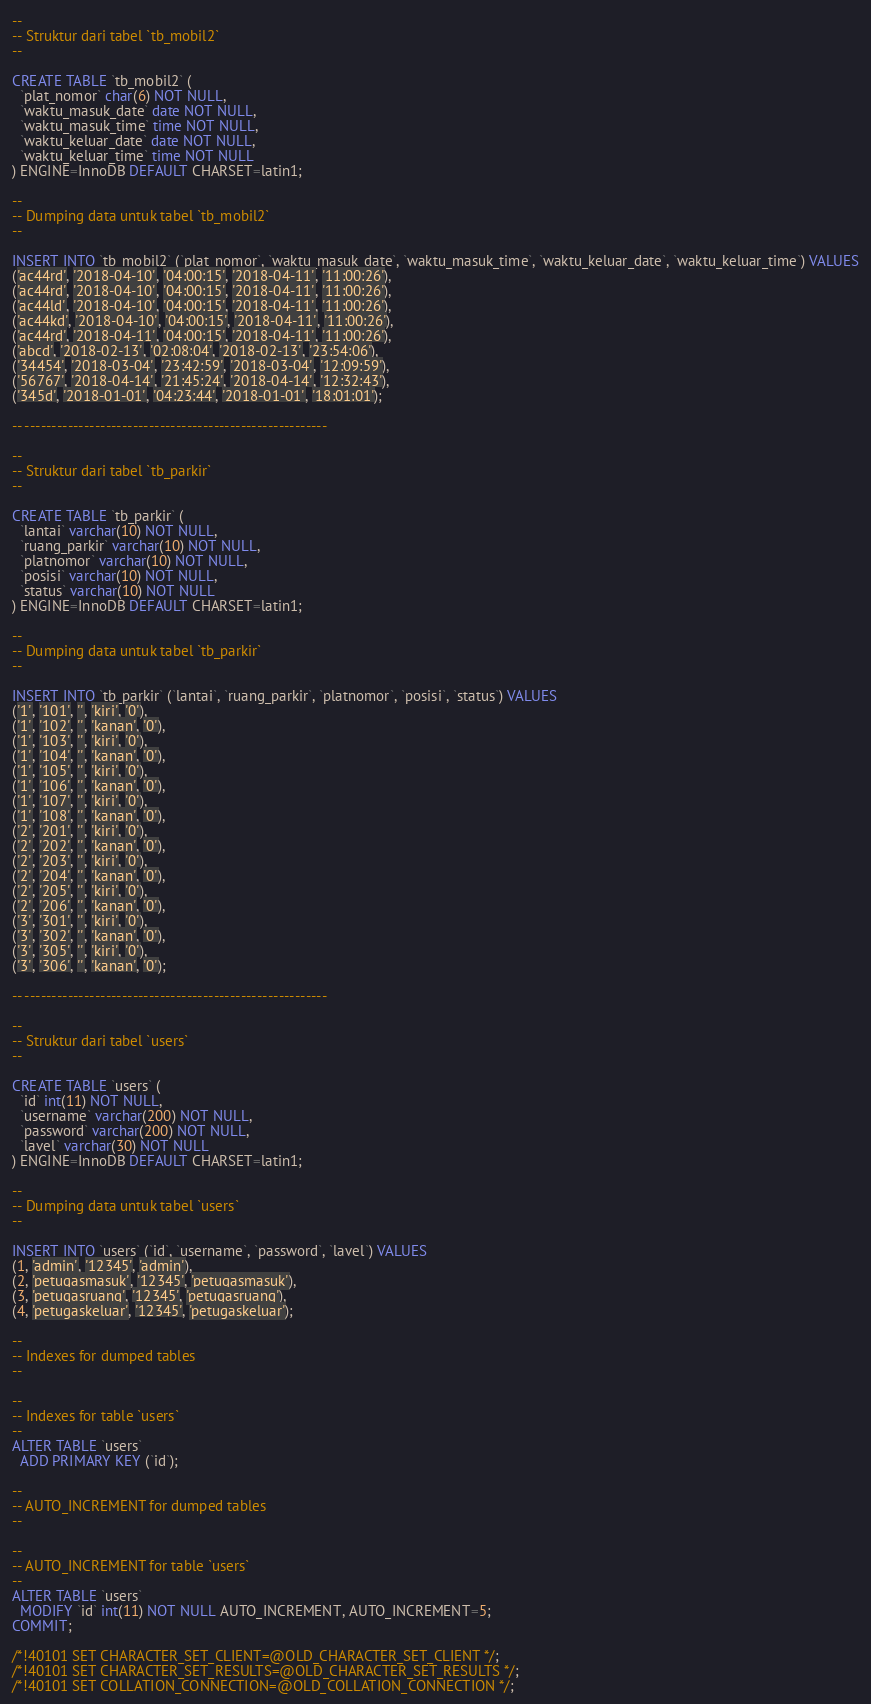<code> <loc_0><loc_0><loc_500><loc_500><_SQL_>
--
-- Struktur dari tabel `tb_mobil2`
--

CREATE TABLE `tb_mobil2` (
  `plat_nomor` char(6) NOT NULL,
  `waktu_masuk_date` date NOT NULL,
  `waktu_masuk_time` time NOT NULL,
  `waktu_keluar_date` date NOT NULL,
  `waktu_keluar_time` time NOT NULL
) ENGINE=InnoDB DEFAULT CHARSET=latin1;

--
-- Dumping data untuk tabel `tb_mobil2`
--

INSERT INTO `tb_mobil2` (`plat_nomor`, `waktu_masuk_date`, `waktu_masuk_time`, `waktu_keluar_date`, `waktu_keluar_time`) VALUES
('ac44rd', '2018-04-10', '04:00:15', '2018-04-11', '11:00:26'),
('ac44rd', '2018-04-10', '04:00:15', '2018-04-11', '11:00:26'),
('ac44ld', '2018-04-10', '04:00:15', '2018-04-11', '11:00:26'),
('ac44kd', '2018-04-10', '04:00:15', '2018-04-11', '11:00:26'),
('ac44rd', '2018-04-11', '04:00:15', '2018-04-11', '11:00:26'),
('abcd', '2018-02-13', '02:08:04', '2018-02-13', '23:54:06'),
('34454', '2018-03-04', '23:42:59', '2018-03-04', '12:09:59'),
('56767', '2018-04-14', '21:45:24', '2018-04-14', '12:32:43'),
('345d', '2018-01-01', '04:23:44', '2018-01-01', '18:01:01');

-- --------------------------------------------------------

--
-- Struktur dari tabel `tb_parkir`
--

CREATE TABLE `tb_parkir` (
  `lantai` varchar(10) NOT NULL,
  `ruang_parkir` varchar(10) NOT NULL,
  `platnomor` varchar(10) NOT NULL,
  `posisi` varchar(10) NOT NULL,
  `status` varchar(10) NOT NULL
) ENGINE=InnoDB DEFAULT CHARSET=latin1;

--
-- Dumping data untuk tabel `tb_parkir`
--

INSERT INTO `tb_parkir` (`lantai`, `ruang_parkir`, `platnomor`, `posisi`, `status`) VALUES
('1', '101', '', 'kiri', '0'),
('1', '102', '', 'kanan', '0'),
('1', '103', '', 'kiri', '0'),
('1', '104', '', 'kanan', '0'),
('1', '105', '', 'kiri', '0'),
('1', '106', '', 'kanan', '0'),
('1', '107', '', 'kiri', '0'),
('1', '108', '', 'kanan', '0'),
('2', '201', '', 'kiri', '0'),
('2', '202', '', 'kanan', '0'),
('2', '203', '', 'kiri', '0'),
('2', '204', '', 'kanan', '0'),
('2', '205', '', 'kiri', '0'),
('2', '206', '', 'kanan', '0'),
('3', '301', '', 'kiri', '0'),
('3', '302', '', 'kanan', '0'),
('3', '305', '', 'kiri', '0'),
('3', '306', '', 'kanan', '0');

-- --------------------------------------------------------

--
-- Struktur dari tabel `users`
--

CREATE TABLE `users` (
  `id` int(11) NOT NULL,
  `username` varchar(200) NOT NULL,
  `password` varchar(200) NOT NULL,
  `lavel` varchar(30) NOT NULL
) ENGINE=InnoDB DEFAULT CHARSET=latin1;

--
-- Dumping data untuk tabel `users`
--

INSERT INTO `users` (`id`, `username`, `password`, `lavel`) VALUES
(1, 'admin', '12345', 'admin'),
(2, 'petugasmasuk', '12345', 'petugasmasuk'),
(3, 'petugasruang', '12345', 'petugasruang'),
(4, 'petugaskeluar', '12345', 'petugaskeluar');

--
-- Indexes for dumped tables
--

--
-- Indexes for table `users`
--
ALTER TABLE `users`
  ADD PRIMARY KEY (`id`);

--
-- AUTO_INCREMENT for dumped tables
--

--
-- AUTO_INCREMENT for table `users`
--
ALTER TABLE `users`
  MODIFY `id` int(11) NOT NULL AUTO_INCREMENT, AUTO_INCREMENT=5;
COMMIT;

/*!40101 SET CHARACTER_SET_CLIENT=@OLD_CHARACTER_SET_CLIENT */;
/*!40101 SET CHARACTER_SET_RESULTS=@OLD_CHARACTER_SET_RESULTS */;
/*!40101 SET COLLATION_CONNECTION=@OLD_COLLATION_CONNECTION */;
</code> 